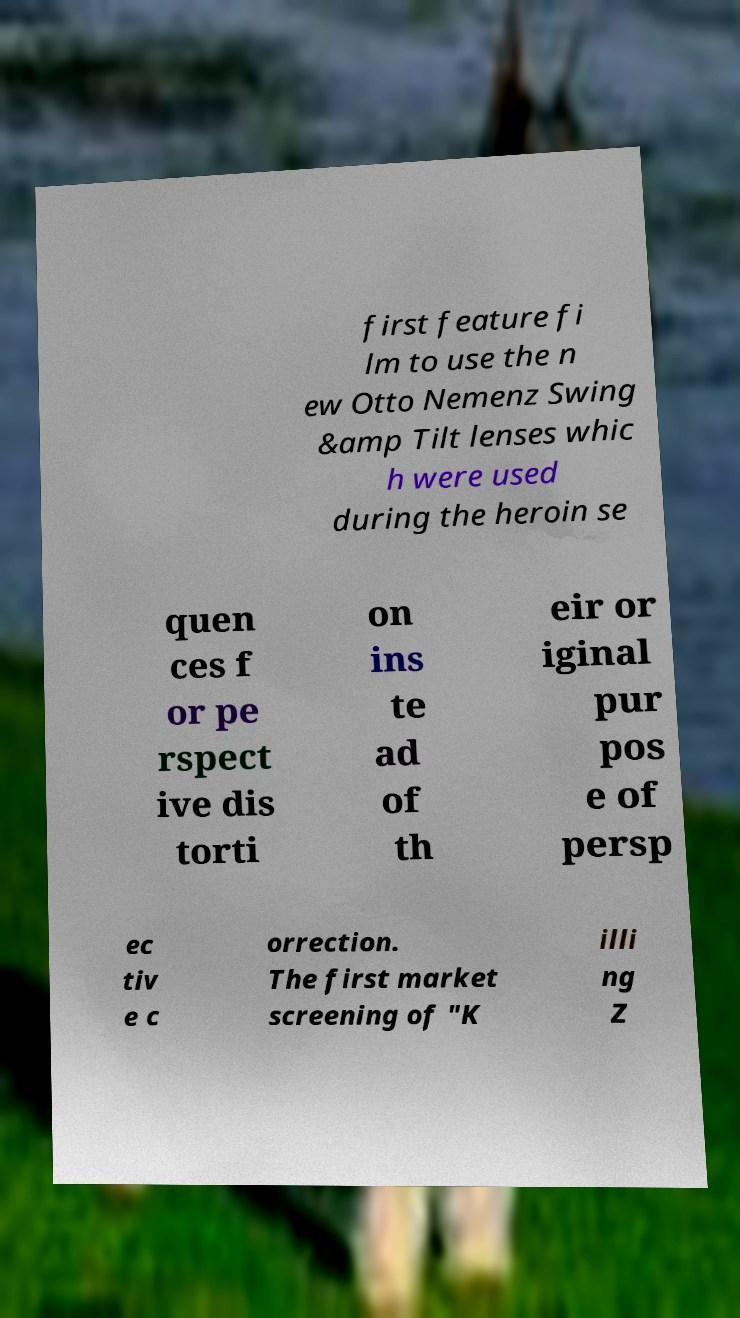Could you extract and type out the text from this image? first feature fi lm to use the n ew Otto Nemenz Swing &amp Tilt lenses whic h were used during the heroin se quen ces f or pe rspect ive dis torti on ins te ad of th eir or iginal pur pos e of persp ec tiv e c orrection. The first market screening of "K illi ng Z 